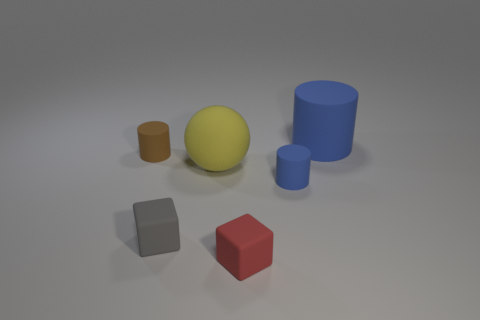There is a large cylinder; does it have the same color as the cylinder that is in front of the big rubber ball?
Ensure brevity in your answer.  Yes. The large yellow object that is left of the matte thing in front of the small gray block is what shape?
Give a very brief answer. Sphere. Are any large green matte things visible?
Make the answer very short. No. The small matte cylinder in front of the big yellow object is what color?
Offer a terse response. Blue. There is a red thing; are there any small rubber cylinders on the left side of it?
Offer a very short reply. Yes. Are there more big blue matte cylinders than large purple metallic objects?
Provide a succinct answer. Yes. The tiny rubber cylinder to the right of the small cylinder that is to the left of the tiny cube on the left side of the red block is what color?
Ensure brevity in your answer.  Blue. There is a large cylinder that is the same material as the red thing; what color is it?
Provide a short and direct response. Blue. What number of things are cylinders behind the sphere or small matte blocks that are behind the red block?
Your response must be concise. 3. There is a cube that is in front of the small gray cube; is its size the same as the matte cylinder left of the gray matte cube?
Your response must be concise. Yes. 